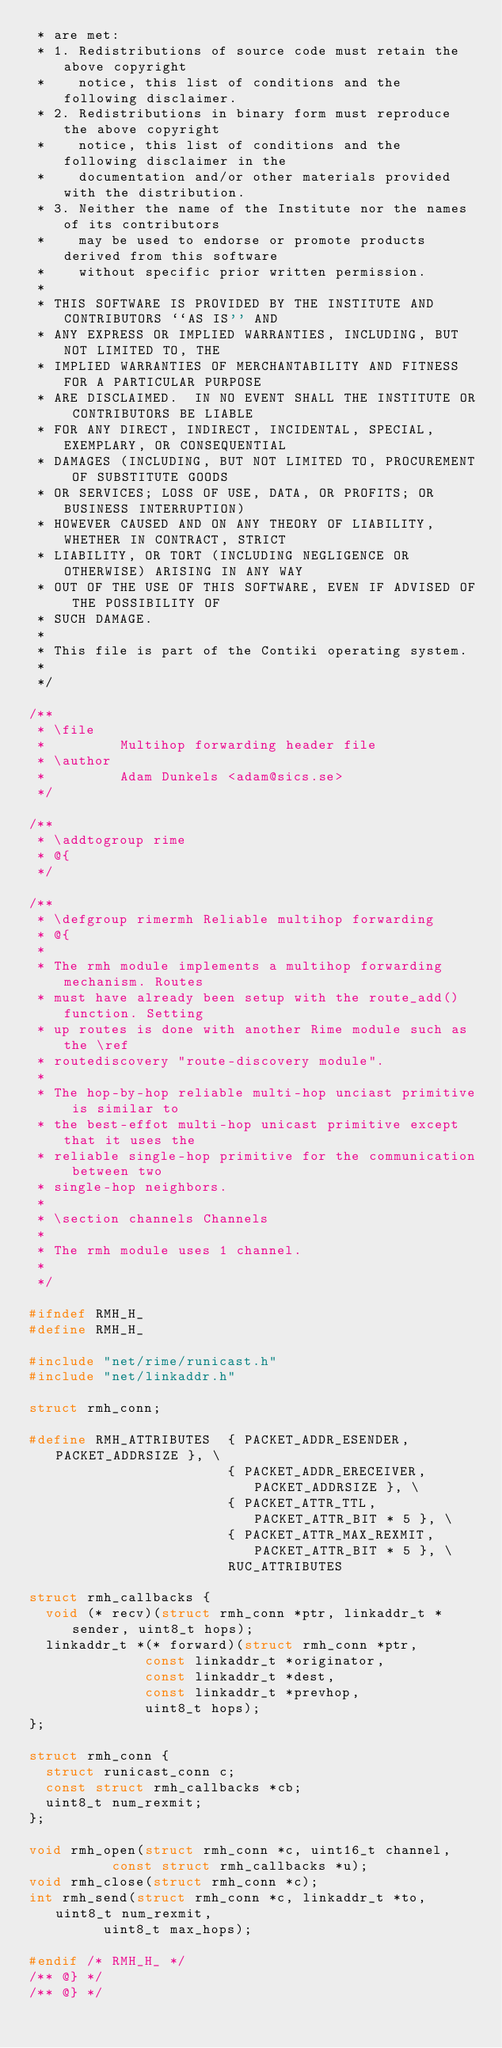<code> <loc_0><loc_0><loc_500><loc_500><_C_> * are met:
 * 1. Redistributions of source code must retain the above copyright
 *    notice, this list of conditions and the following disclaimer.
 * 2. Redistributions in binary form must reproduce the above copyright
 *    notice, this list of conditions and the following disclaimer in the
 *    documentation and/or other materials provided with the distribution.
 * 3. Neither the name of the Institute nor the names of its contributors
 *    may be used to endorse or promote products derived from this software
 *    without specific prior written permission.
 *
 * THIS SOFTWARE IS PROVIDED BY THE INSTITUTE AND CONTRIBUTORS ``AS IS'' AND
 * ANY EXPRESS OR IMPLIED WARRANTIES, INCLUDING, BUT NOT LIMITED TO, THE
 * IMPLIED WARRANTIES OF MERCHANTABILITY AND FITNESS FOR A PARTICULAR PURPOSE
 * ARE DISCLAIMED.  IN NO EVENT SHALL THE INSTITUTE OR CONTRIBUTORS BE LIABLE
 * FOR ANY DIRECT, INDIRECT, INCIDENTAL, SPECIAL, EXEMPLARY, OR CONSEQUENTIAL
 * DAMAGES (INCLUDING, BUT NOT LIMITED TO, PROCUREMENT OF SUBSTITUTE GOODS
 * OR SERVICES; LOSS OF USE, DATA, OR PROFITS; OR BUSINESS INTERRUPTION)
 * HOWEVER CAUSED AND ON ANY THEORY OF LIABILITY, WHETHER IN CONTRACT, STRICT
 * LIABILITY, OR TORT (INCLUDING NEGLIGENCE OR OTHERWISE) ARISING IN ANY WAY
 * OUT OF THE USE OF THIS SOFTWARE, EVEN IF ADVISED OF THE POSSIBILITY OF
 * SUCH DAMAGE.
 *
 * This file is part of the Contiki operating system.
 *
 */

/**
 * \file
 *         Multihop forwarding header file
 * \author
 *         Adam Dunkels <adam@sics.se>
 */

/**
 * \addtogroup rime
 * @{
 */

/**
 * \defgroup rimermh Reliable multihop forwarding
 * @{
 *
 * The rmh module implements a multihop forwarding mechanism. Routes
 * must have already been setup with the route_add() function. Setting
 * up routes is done with another Rime module such as the \ref
 * routediscovery "route-discovery module".
 *
 * The hop-by-hop reliable multi-hop unciast primitive is similar to
 * the best-effot multi-hop unicast primitive except that it uses the
 * reliable single-hop primitive for the communication between two
 * single-hop neighbors.
 *
 * \section channels Channels
 *
 * The rmh module uses 1 channel.
 *
 */

#ifndef RMH_H_
#define RMH_H_

#include "net/rime/runicast.h"
#include "net/linkaddr.h"

struct rmh_conn;

#define RMH_ATTRIBUTES  { PACKET_ADDR_ESENDER, PACKET_ADDRSIZE }, \
                        { PACKET_ADDR_ERECEIVER, PACKET_ADDRSIZE }, \
                        { PACKET_ATTR_TTL, PACKET_ATTR_BIT * 5 }, \
                        { PACKET_ATTR_MAX_REXMIT, PACKET_ATTR_BIT * 5 }, \
                        RUC_ATTRIBUTES

struct rmh_callbacks {
  void (* recv)(struct rmh_conn *ptr, linkaddr_t *sender, uint8_t hops);
  linkaddr_t *(* forward)(struct rmh_conn *ptr,
			  const linkaddr_t *originator,
			  const linkaddr_t *dest,
			  const linkaddr_t *prevhop,
			  uint8_t hops);
};

struct rmh_conn {
  struct runicast_conn c;
  const struct rmh_callbacks *cb;
  uint8_t num_rexmit;
};

void rmh_open(struct rmh_conn *c, uint16_t channel,
	      const struct rmh_callbacks *u);
void rmh_close(struct rmh_conn *c);
int rmh_send(struct rmh_conn *c, linkaddr_t *to, uint8_t num_rexmit,
	     uint8_t max_hops);

#endif /* RMH_H_ */
/** @} */
/** @} */
</code> 